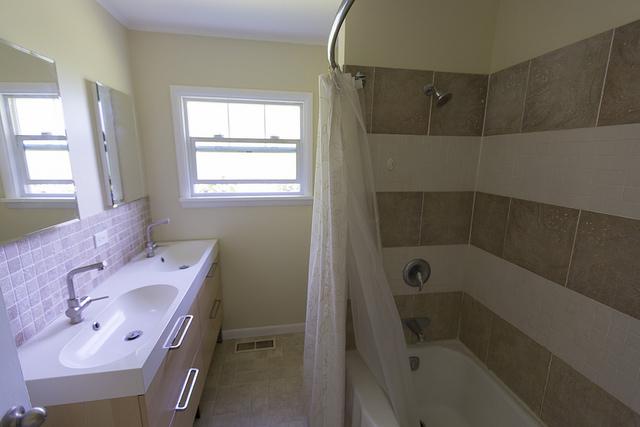What color is the window sill?
Write a very short answer. White. Is the shower over the bathtub?
Give a very brief answer. Yes. Is this layout a tad unusual for a bathroom?
Quick response, please. No. Is the window open or closed?
Be succinct. Open. How many tiles are in the room?
Answer briefly. 100. 